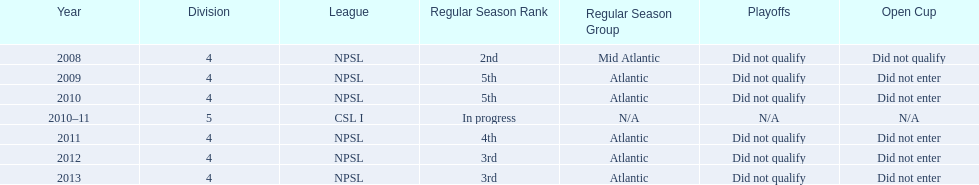Using the data, what should be the next year they will play? 2014. 